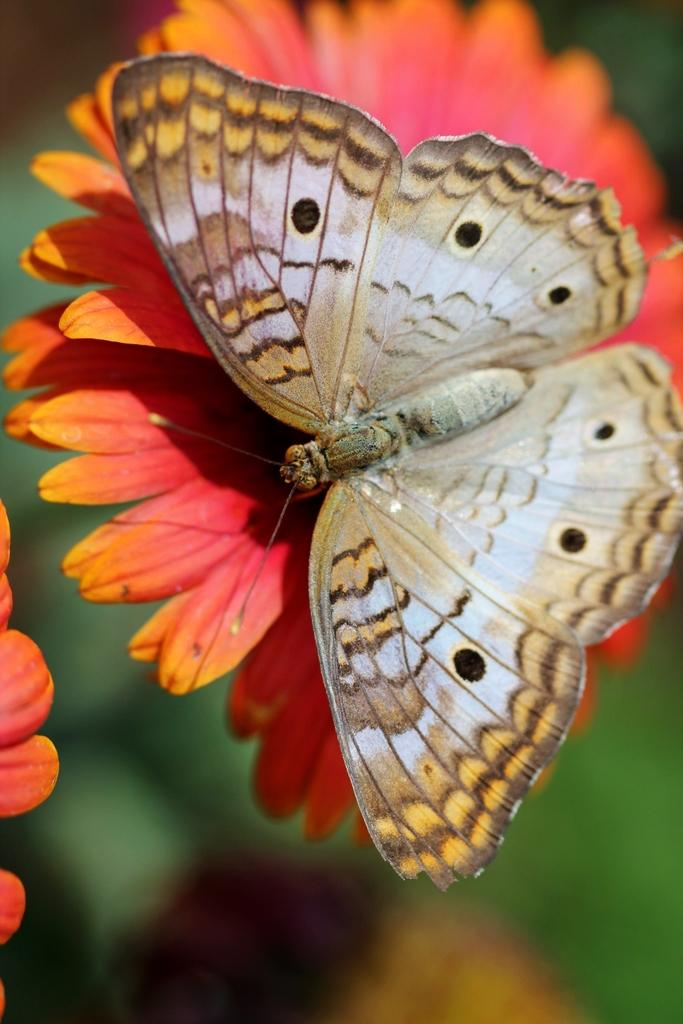What is the main subject of the image? The main subject of the image is a butterfly. Where is the butterfly located in the image? The butterfly is on a flower. Can you describe the background of the image? The background of the image is blurry. What is the butterfly talking about with the goat in the image? There is no goat present in the image, so the butterfly cannot be talking to a goat. 